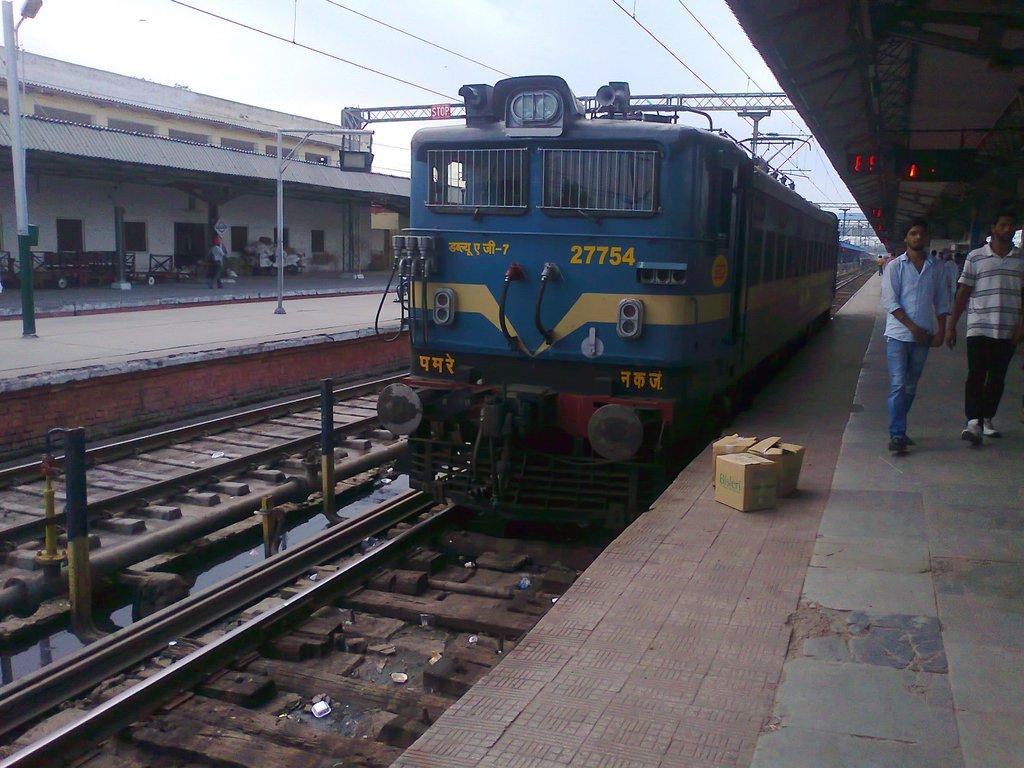In one or two sentences, can you explain what this image depicts? In this image there is a railway station, in that state there are train tracks, on one track there is a train, on the right side two people are walking. 